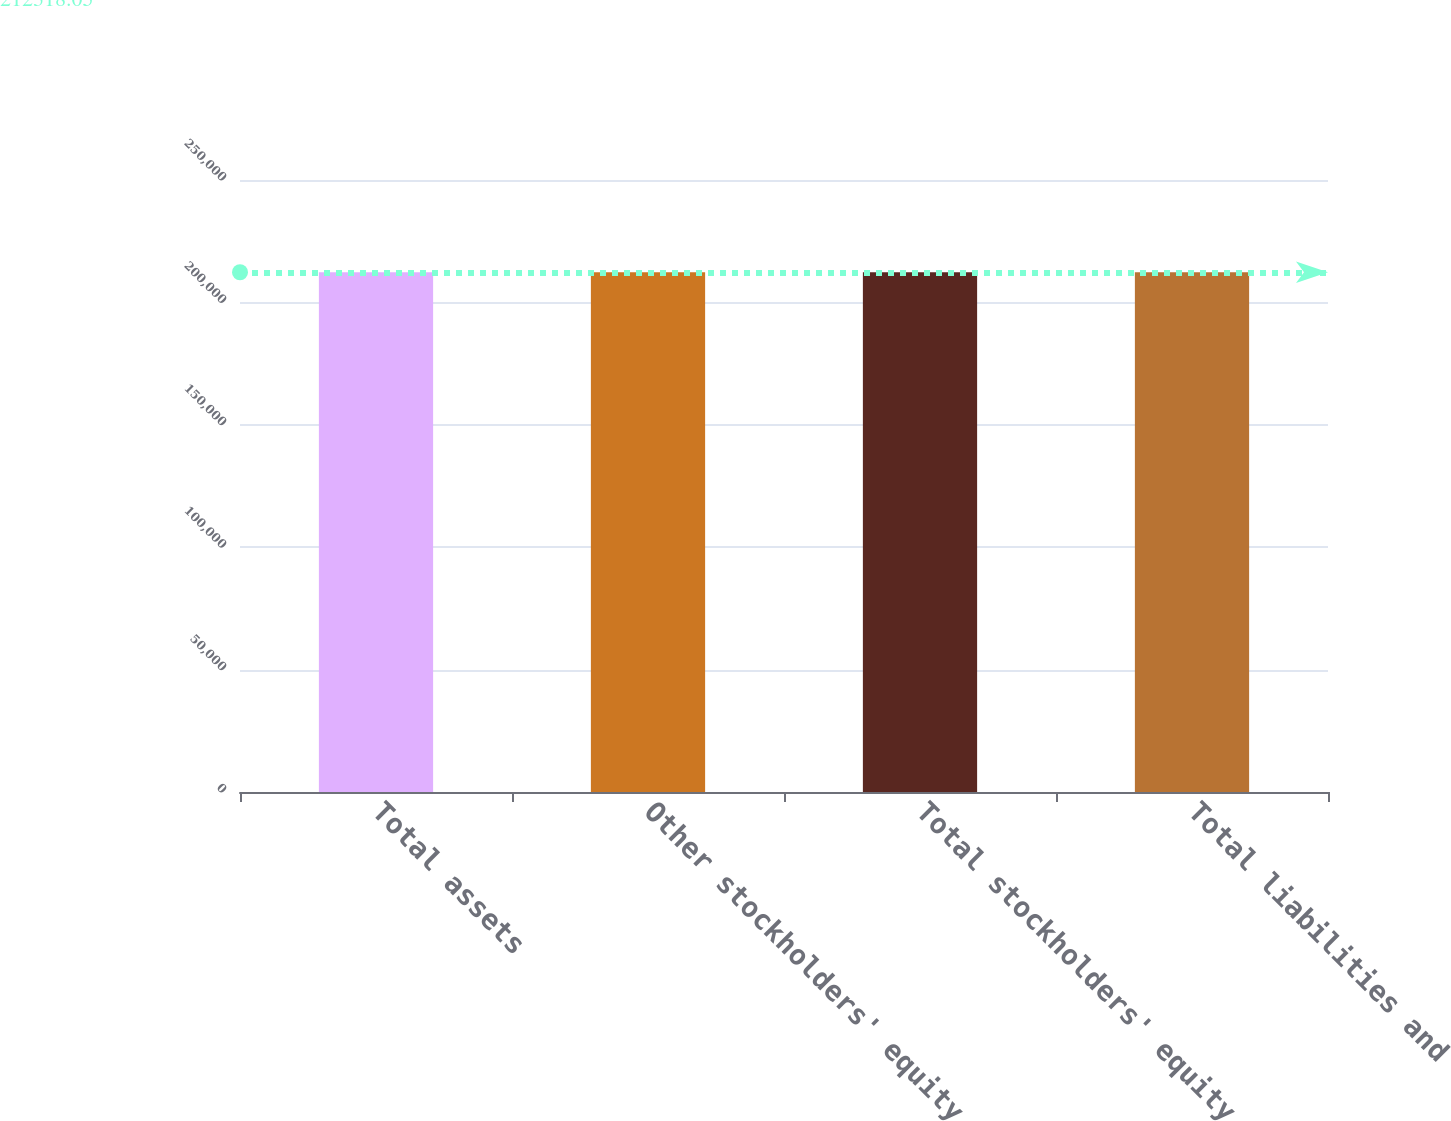Convert chart. <chart><loc_0><loc_0><loc_500><loc_500><bar_chart><fcel>Total assets<fcel>Other stockholders' equity<fcel>Total stockholders' equity<fcel>Total liabilities and<nl><fcel>212318<fcel>212318<fcel>212318<fcel>212318<nl></chart> 